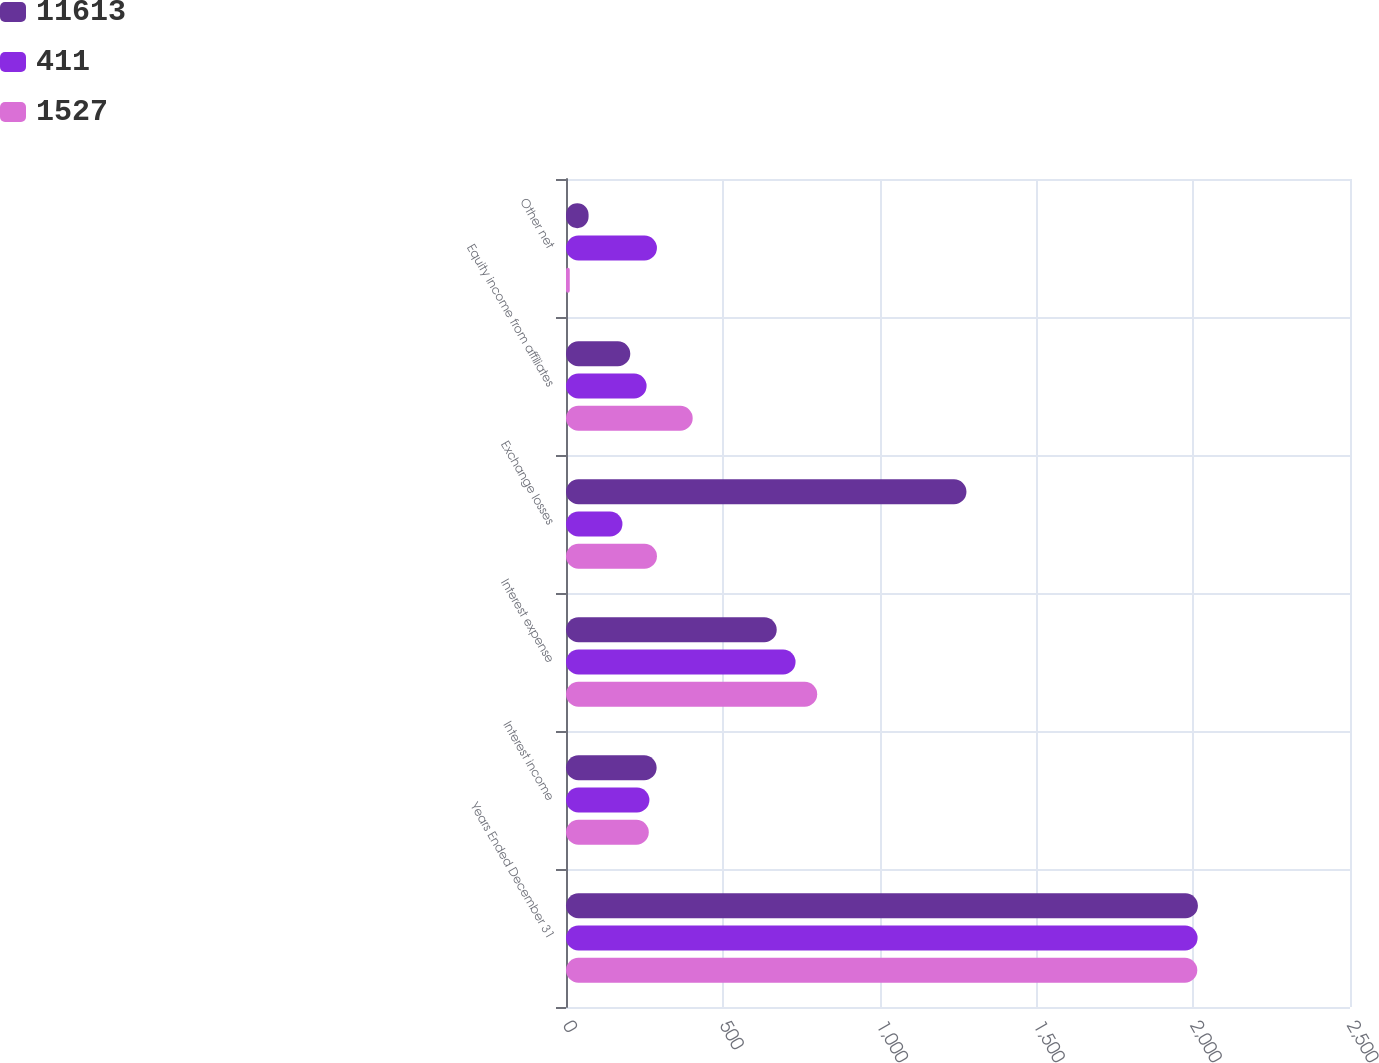Convert chart. <chart><loc_0><loc_0><loc_500><loc_500><stacked_bar_chart><ecel><fcel>Years Ended December 31<fcel>Interest income<fcel>Interest expense<fcel>Exchange losses<fcel>Equity income from affiliates<fcel>Other net<nl><fcel>11613<fcel>2015<fcel>289<fcel>672<fcel>1277<fcel>205<fcel>72<nl><fcel>411<fcel>2014<fcel>266<fcel>732<fcel>180<fcel>257<fcel>290<nl><fcel>1527<fcel>2013<fcel>264<fcel>801<fcel>290<fcel>404<fcel>12<nl></chart> 